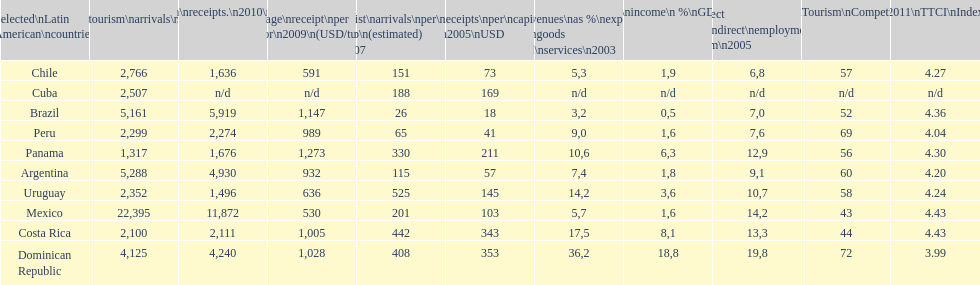How many dollars on average did brazil receive per tourist in 2009? 1,147. 